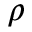Convert formula to latex. <formula><loc_0><loc_0><loc_500><loc_500>\rho</formula> 